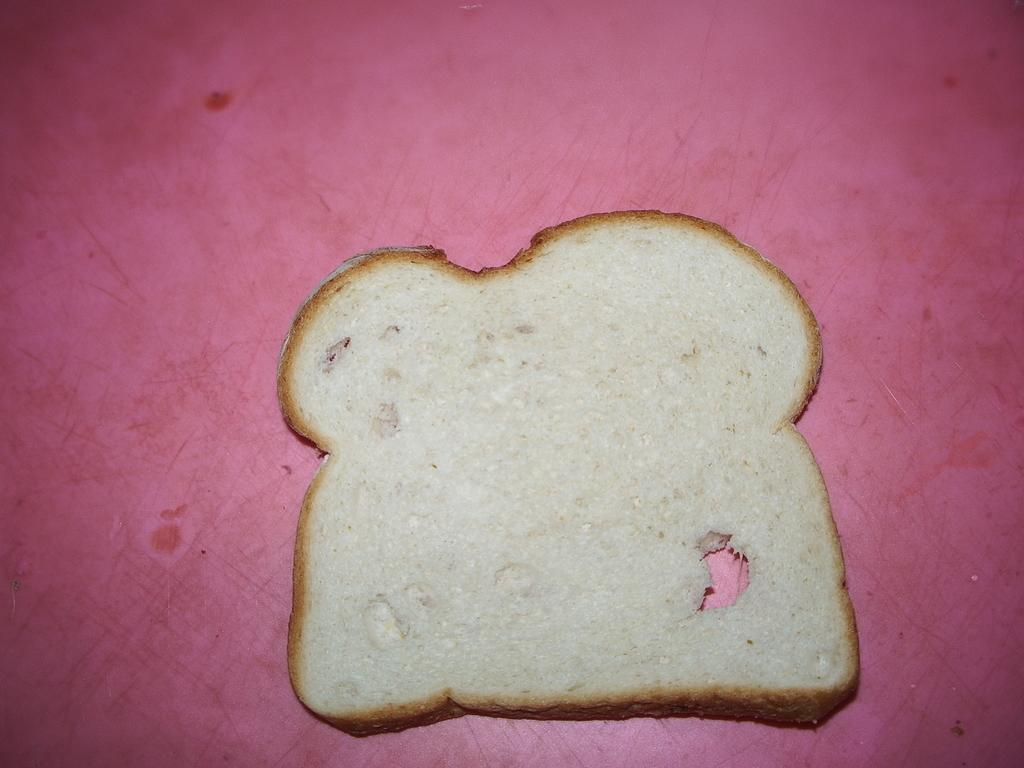What type of food is visible in the image? The food in the image has white and brown colors. Can you describe the surface on which the food is placed? The food is on a pink surface. Where is the rat hiding in the image? There is no rat present in the image. What type of vase can be seen holding the food in the image? There is no vase present in the image; the food is on a pink surface. 